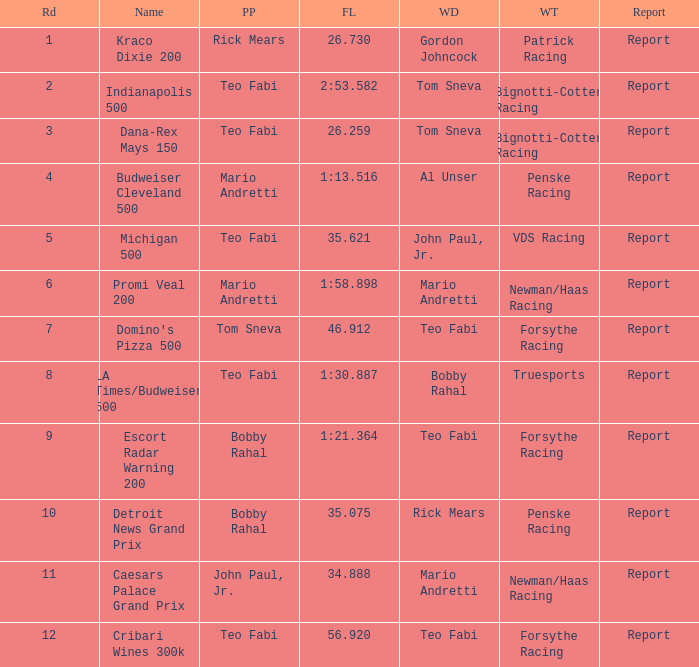How many winning drivers were there in the race that had a fastest lap time of 56.920? 1.0. Can you give me this table as a dict? {'header': ['Rd', 'Name', 'PP', 'FL', 'WD', 'WT', 'Report'], 'rows': [['1', 'Kraco Dixie 200', 'Rick Mears', '26.730', 'Gordon Johncock', 'Patrick Racing', 'Report'], ['2', 'Indianapolis 500', 'Teo Fabi', '2:53.582', 'Tom Sneva', 'Bignotti-Cotter Racing', 'Report'], ['3', 'Dana-Rex Mays 150', 'Teo Fabi', '26.259', 'Tom Sneva', 'Bignotti-Cotter Racing', 'Report'], ['4', 'Budweiser Cleveland 500', 'Mario Andretti', '1:13.516', 'Al Unser', 'Penske Racing', 'Report'], ['5', 'Michigan 500', 'Teo Fabi', '35.621', 'John Paul, Jr.', 'VDS Racing', 'Report'], ['6', 'Promi Veal 200', 'Mario Andretti', '1:58.898', 'Mario Andretti', 'Newman/Haas Racing', 'Report'], ['7', "Domino's Pizza 500", 'Tom Sneva', '46.912', 'Teo Fabi', 'Forsythe Racing', 'Report'], ['8', 'LA Times/Budweiser 500', 'Teo Fabi', '1:30.887', 'Bobby Rahal', 'Truesports', 'Report'], ['9', 'Escort Radar Warning 200', 'Bobby Rahal', '1:21.364', 'Teo Fabi', 'Forsythe Racing', 'Report'], ['10', 'Detroit News Grand Prix', 'Bobby Rahal', '35.075', 'Rick Mears', 'Penske Racing', 'Report'], ['11', 'Caesars Palace Grand Prix', 'John Paul, Jr.', '34.888', 'Mario Andretti', 'Newman/Haas Racing', 'Report'], ['12', 'Cribari Wines 300k', 'Teo Fabi', '56.920', 'Teo Fabi', 'Forsythe Racing', 'Report']]} 